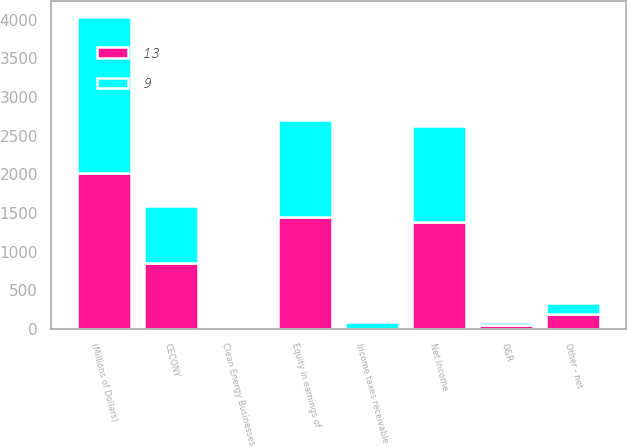<chart> <loc_0><loc_0><loc_500><loc_500><stacked_bar_chart><ecel><fcel>(Millions of Dollars)<fcel>Net Income<fcel>Equity in earnings of<fcel>CECONY<fcel>O&R<fcel>Clean Energy Businesses<fcel>Income taxes receivable<fcel>Other - net<nl><fcel>13<fcel>2018<fcel>1382<fcel>1447<fcel>846<fcel>46<fcel>15<fcel>2<fcel>187<nl><fcel>9<fcel>2016<fcel>1245<fcel>1254<fcel>744<fcel>43<fcel>10<fcel>87<fcel>152<nl></chart> 